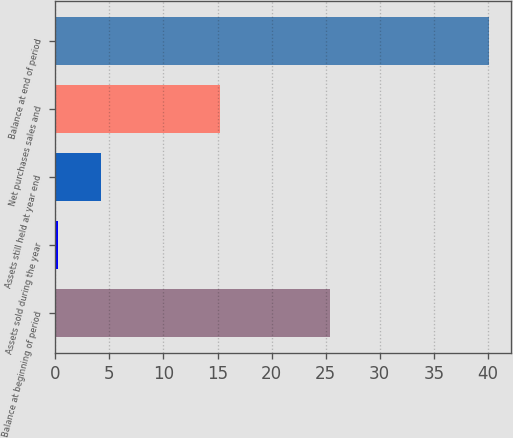<chart> <loc_0><loc_0><loc_500><loc_500><bar_chart><fcel>Balance at beginning of period<fcel>Assets sold during the year<fcel>Assets still held at year end<fcel>Net purchases sales and<fcel>Balance at end of period<nl><fcel>25.4<fcel>0.2<fcel>4.19<fcel>15.2<fcel>40.1<nl></chart> 